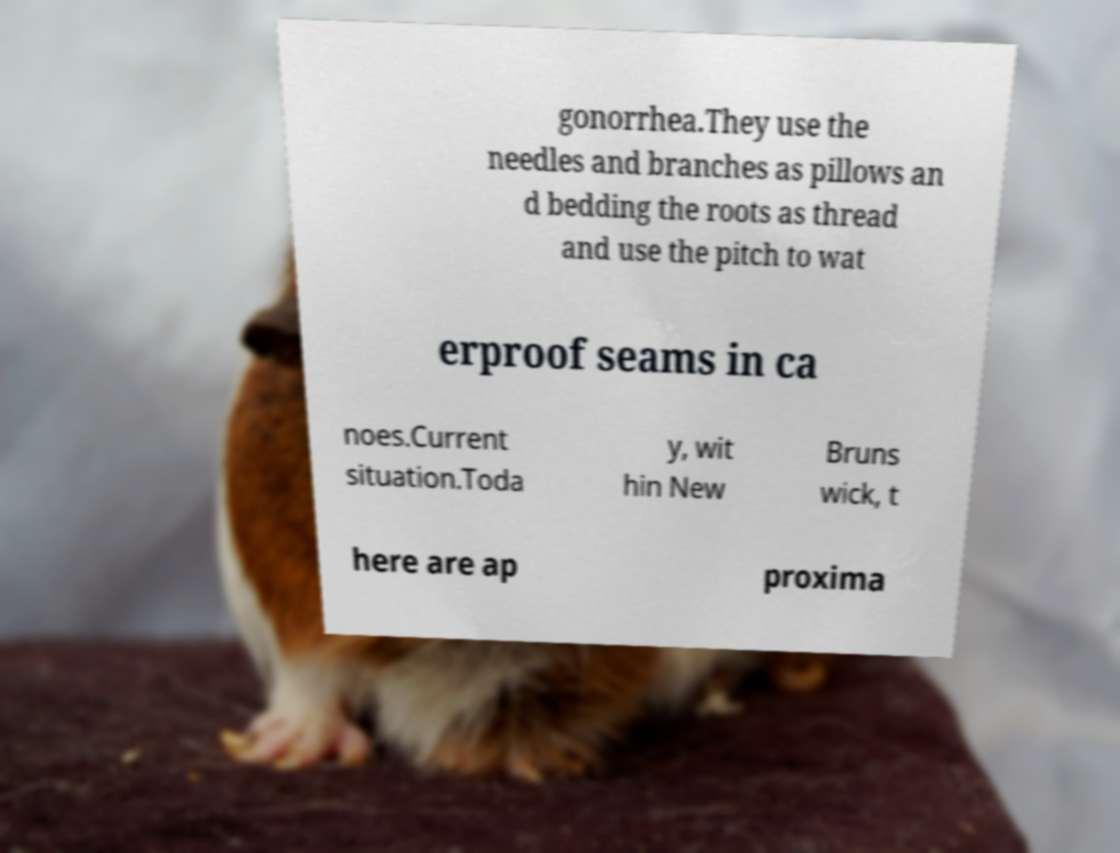I need the written content from this picture converted into text. Can you do that? gonorrhea.They use the needles and branches as pillows an d bedding the roots as thread and use the pitch to wat erproof seams in ca noes.Current situation.Toda y, wit hin New Bruns wick, t here are ap proxima 